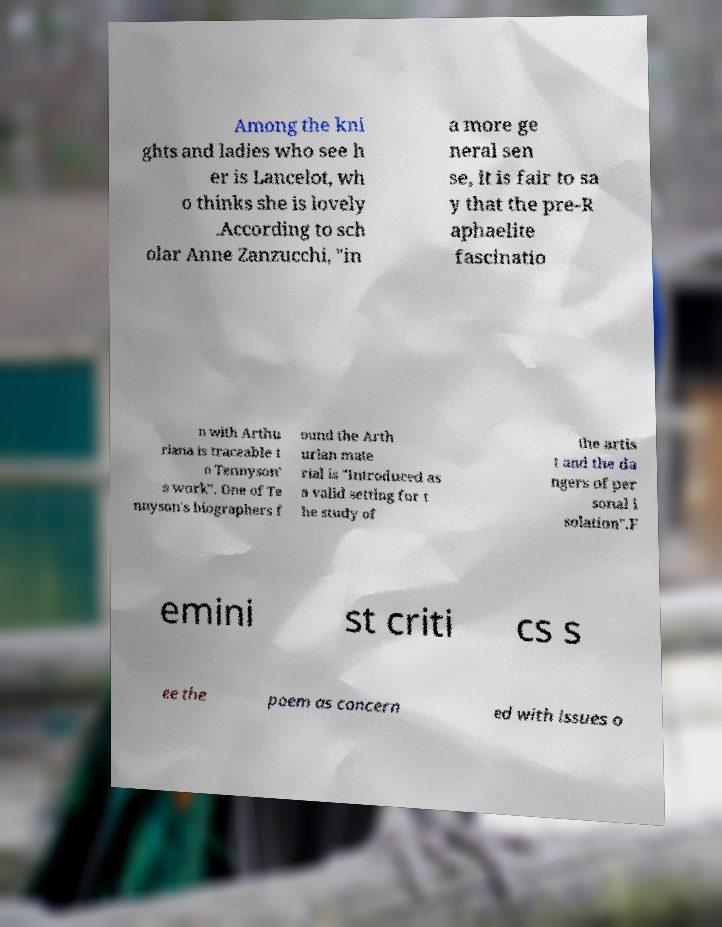For documentation purposes, I need the text within this image transcribed. Could you provide that? Among the kni ghts and ladies who see h er is Lancelot, wh o thinks she is lovely .According to sch olar Anne Zanzucchi, "in a more ge neral sen se, it is fair to sa y that the pre-R aphaelite fascinatio n with Arthu riana is traceable t o Tennyson' s work". One of Te nnyson's biographers f ound the Arth urian mate rial is "Introduced as a valid setting for t he study of the artis t and the da ngers of per sonal i solation".F emini st criti cs s ee the poem as concern ed with issues o 